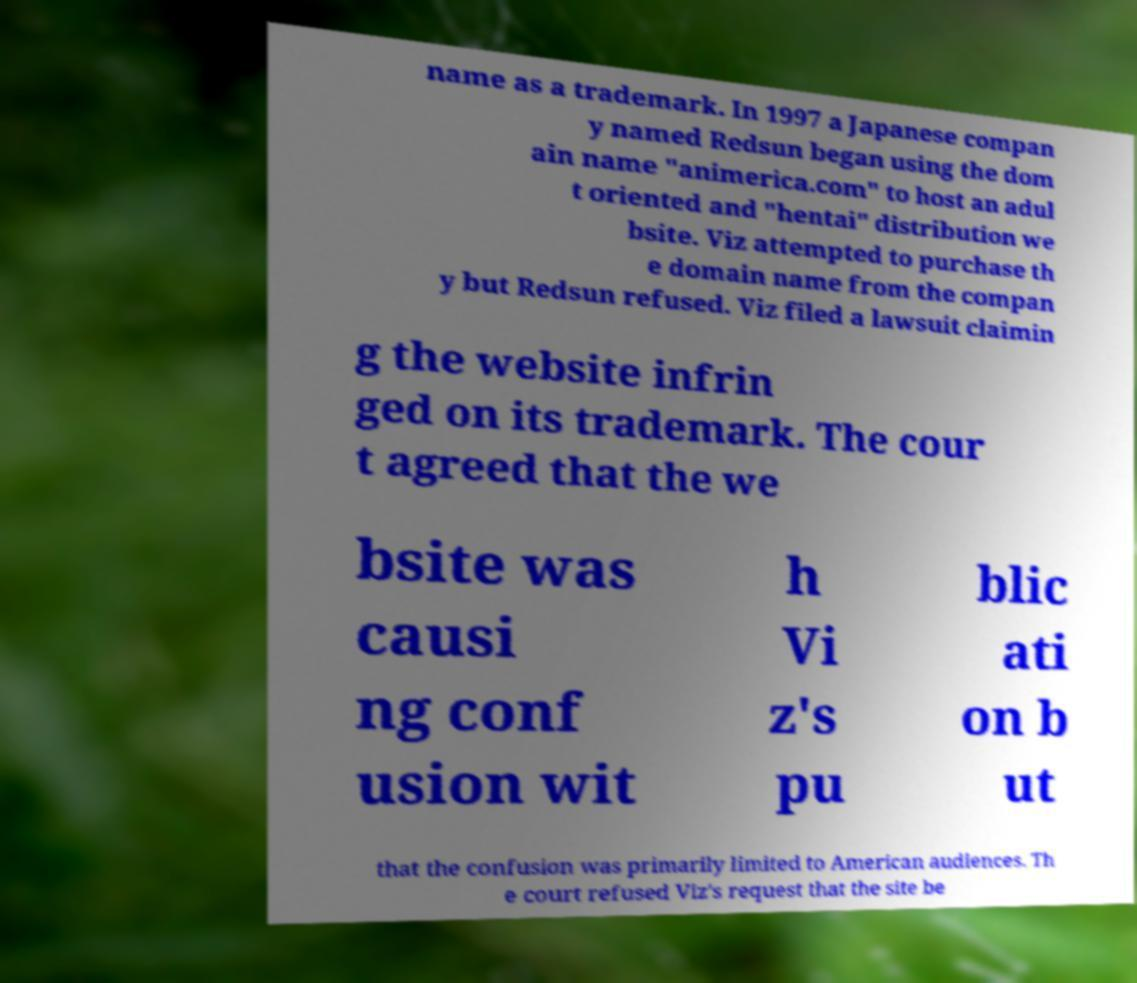Could you extract and type out the text from this image? name as a trademark. In 1997 a Japanese compan y named Redsun began using the dom ain name "animerica.com" to host an adul t oriented and "hentai" distribution we bsite. Viz attempted to purchase th e domain name from the compan y but Redsun refused. Viz filed a lawsuit claimin g the website infrin ged on its trademark. The cour t agreed that the we bsite was causi ng conf usion wit h Vi z's pu blic ati on b ut that the confusion was primarily limited to American audiences. Th e court refused Viz's request that the site be 